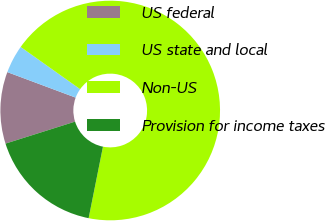Convert chart. <chart><loc_0><loc_0><loc_500><loc_500><pie_chart><fcel>US federal<fcel>US state and local<fcel>Non-US<fcel>Provision for income taxes<nl><fcel>10.56%<fcel>4.14%<fcel>68.33%<fcel>16.98%<nl></chart> 